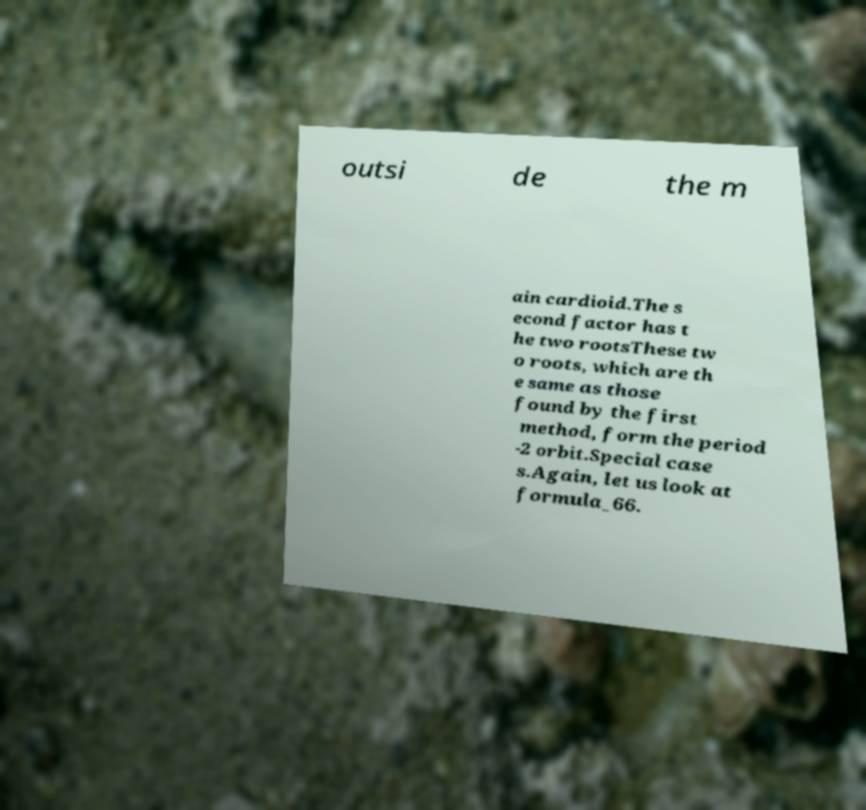Can you accurately transcribe the text from the provided image for me? outsi de the m ain cardioid.The s econd factor has t he two rootsThese tw o roots, which are th e same as those found by the first method, form the period -2 orbit.Special case s.Again, let us look at formula_66. 